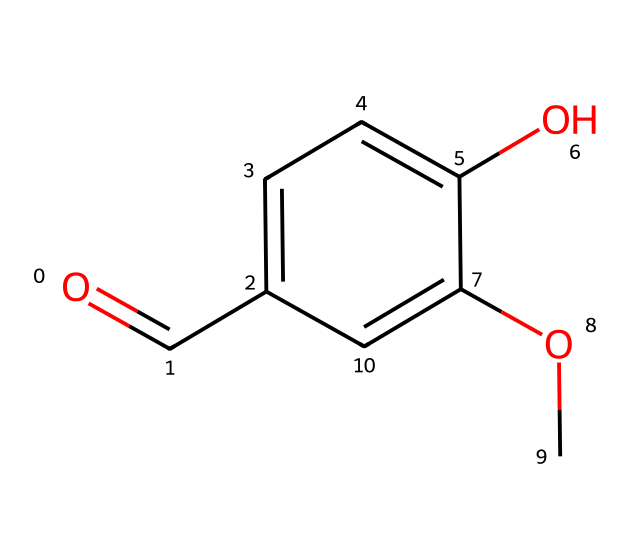What is the molecular formula of vanillin? To determine the molecular formula, we count the number of each type of atom in the chemical structure. The structure has 8 carbons (C), 8 hydrogens (H), and 3 oxygens (O). Therefore, the molecular formula is C8H8O3.
Answer: C8H8O3 How many hydroxyl groups are present in the structure? The structure contains one -OH (hydroxyl) group attached to the benzene ring. A hydroxyl group is characterized by the oxygen attached to hydrogen, which appears as a single -OH in the formula.
Answer: 1 What type of functional group does vanillin contain? The structure shows the presence of an aldehyde functional group, indicated by the -CHO (carbonyl) part of the molecule at the end of the chain. This group is characteristic of aldehydes.
Answer: aldehyde Which part of the structure contributes to its sweet aroma? In flavor and fragrance chemistry, the aromatic ring (the benzene-like section) is primarily responsible for the characteristic sweet aroma. The substitutions on the ring, such as the adjacent -OCH3 group, enhance this effect.
Answer: aromatic ring How many double bonds are present in the vanillin structure? Analyzing the structure, there is one double bond between the carbon and oxygen in the aldehyde group, and another double bond between two carbons in the benzene ring, resulting in a total of 3 double bonds in the molecule.
Answer: 3 What makes vanillin an important compound in flavoring? Vanillin is known for its ability to mimic the flavor of vanilla beans, making it a cost-effective and versatile flavoring agent. Its unique molecular structure allows it to interact well with taste receptors.
Answer: versatility 